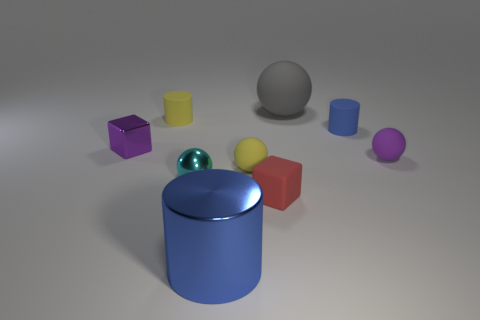Subtract all tiny rubber cylinders. How many cylinders are left? 1 Subtract all balls. How many objects are left? 5 Subtract 0 gray cylinders. How many objects are left? 9 Subtract 1 spheres. How many spheres are left? 3 Subtract all gray cubes. Subtract all cyan balls. How many cubes are left? 2 Subtract all green cylinders. How many purple blocks are left? 1 Subtract all big green metallic cubes. Subtract all large cylinders. How many objects are left? 8 Add 4 cyan metal things. How many cyan metal things are left? 5 Add 9 tiny purple rubber spheres. How many tiny purple rubber spheres exist? 10 Add 1 gray balls. How many objects exist? 10 